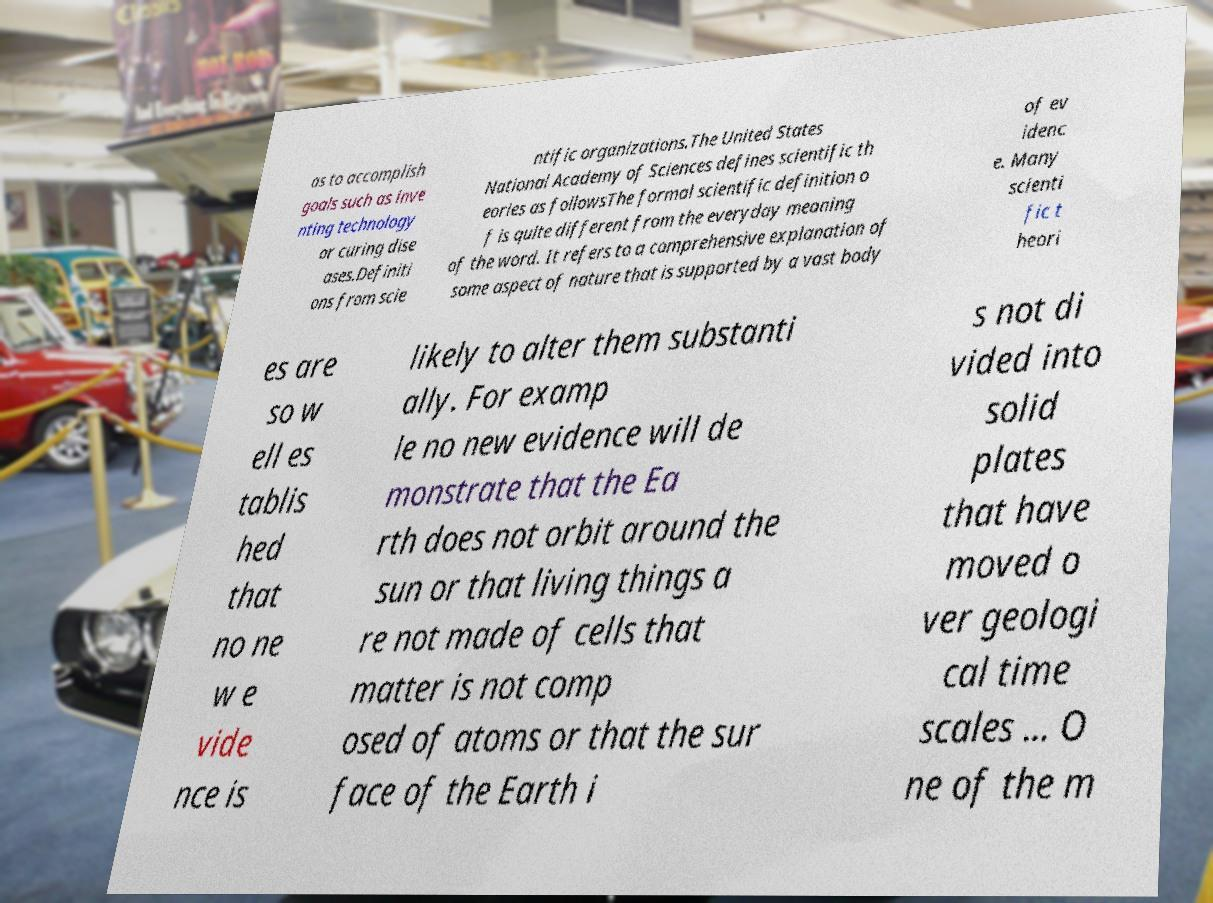Could you extract and type out the text from this image? as to accomplish goals such as inve nting technology or curing dise ases.Definiti ons from scie ntific organizations.The United States National Academy of Sciences defines scientific th eories as followsThe formal scientific definition o f is quite different from the everyday meaning of the word. It refers to a comprehensive explanation of some aspect of nature that is supported by a vast body of ev idenc e. Many scienti fic t heori es are so w ell es tablis hed that no ne w e vide nce is likely to alter them substanti ally. For examp le no new evidence will de monstrate that the Ea rth does not orbit around the sun or that living things a re not made of cells that matter is not comp osed of atoms or that the sur face of the Earth i s not di vided into solid plates that have moved o ver geologi cal time scales ... O ne of the m 